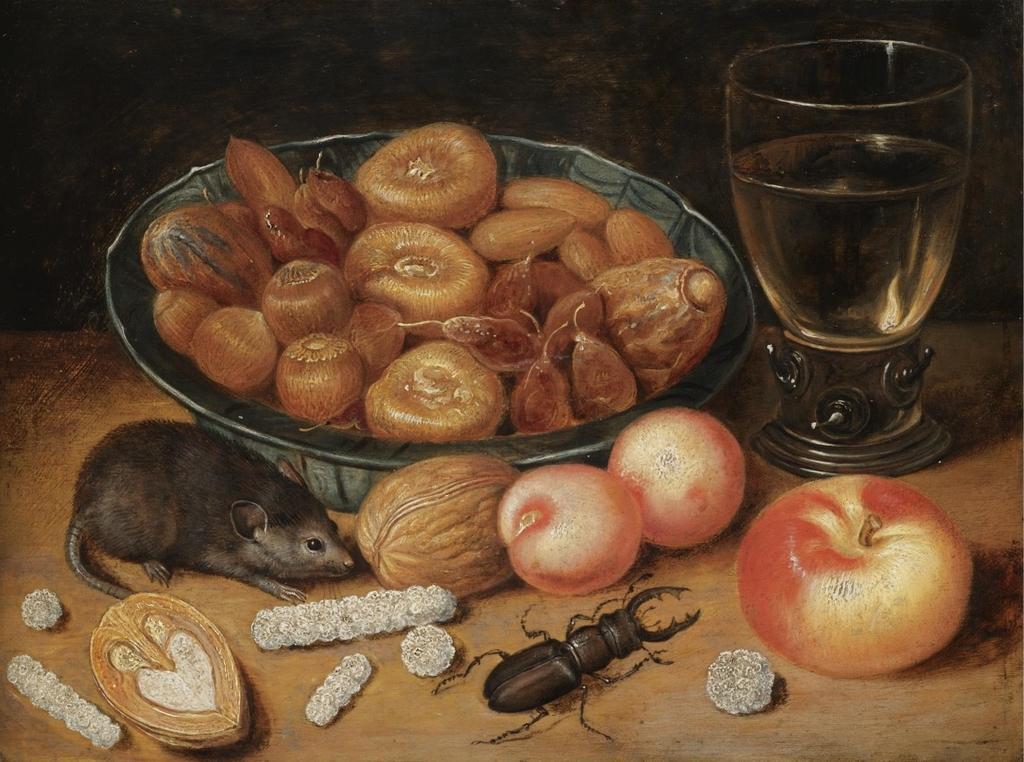Can you describe this image briefly? In the center of the image there is a platform. On the platform, we can see a bowl, glass, insect, mouse and some food items. And we can see the dark background. 